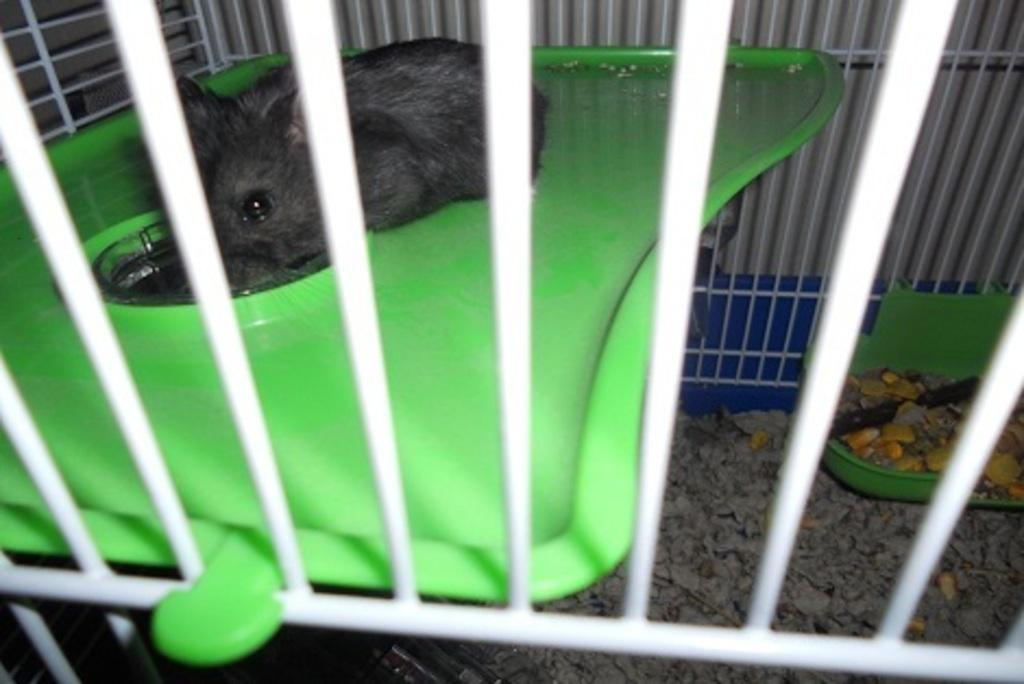What animal is present on the table in the image? There is a rat on the table in the image. How is the rat positioned in relation to the table? The rat is behind a railing. What type of food can be seen on the right side of the image? There is food on a plate on the right side of the image. What object is located at the bottom of the image? There is a marble at the bottom of the image. What type of breakfast is the rat eating in the image? There is no breakfast present in the image, as it only features a rat behind a railing and food on a plate. What is the zinc content of the marble at the bottom of the image? There is no information about the zinc content of the marble, as it is not mentioned in the provided facts. 